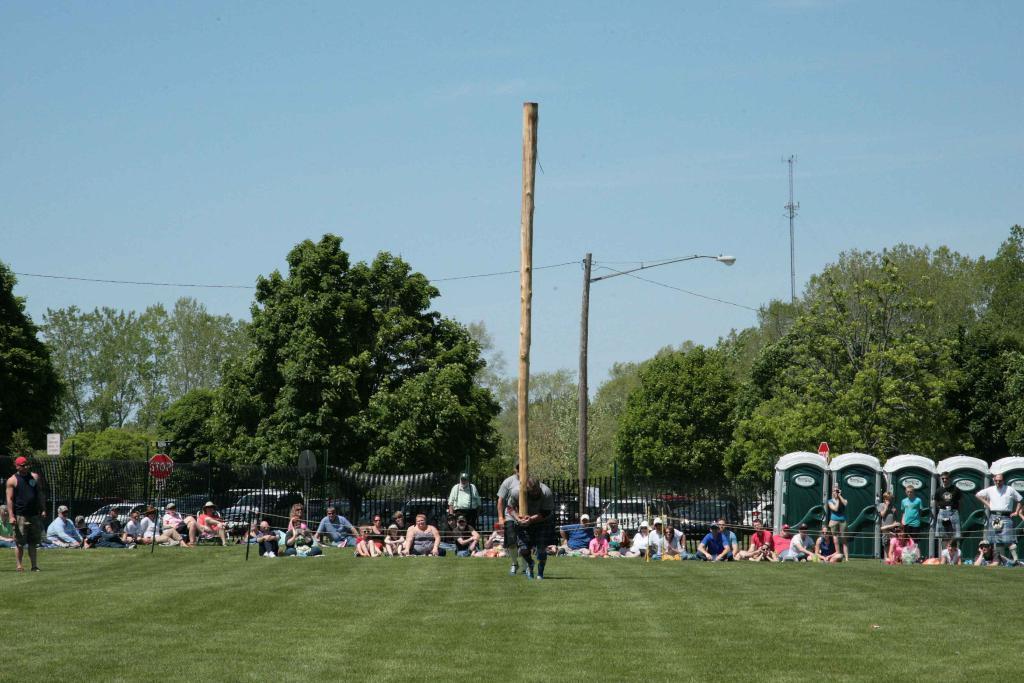Describe this image in one or two sentences. This picture shows few people are seated and few are standing and we see a man holding a wooden bark in his hands and walking and we see another man on the back and we see a pole light and a tower and we see trees and blue cloudy Sky and we see few sign boards and portable toilets on the side and we see grass on the ground. 